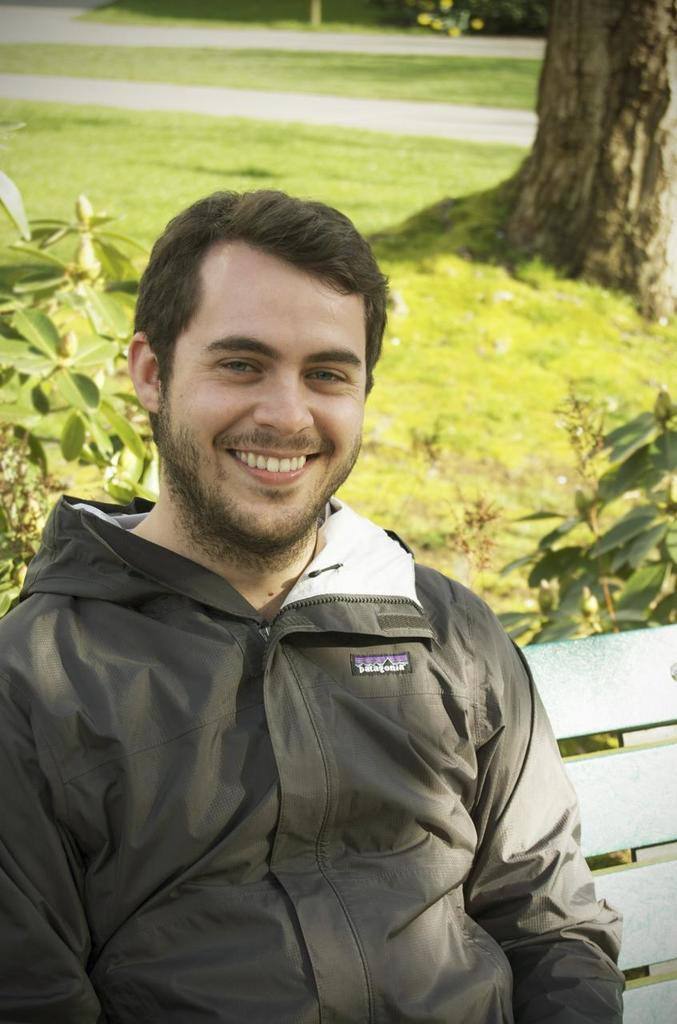Who is present in the image? There is a man in the image. What is the man wearing? The man is wearing a black jacket. What is the man doing in the image? The man is sitting on a bench. What type of vegetation can be seen in the image? There is grass, a plant, and a tree stem in the image. What is the range of the van in the image? There is no van present in the image. Where was the man born, as depicted in the image? The image does not provide any information about the man's birth. 